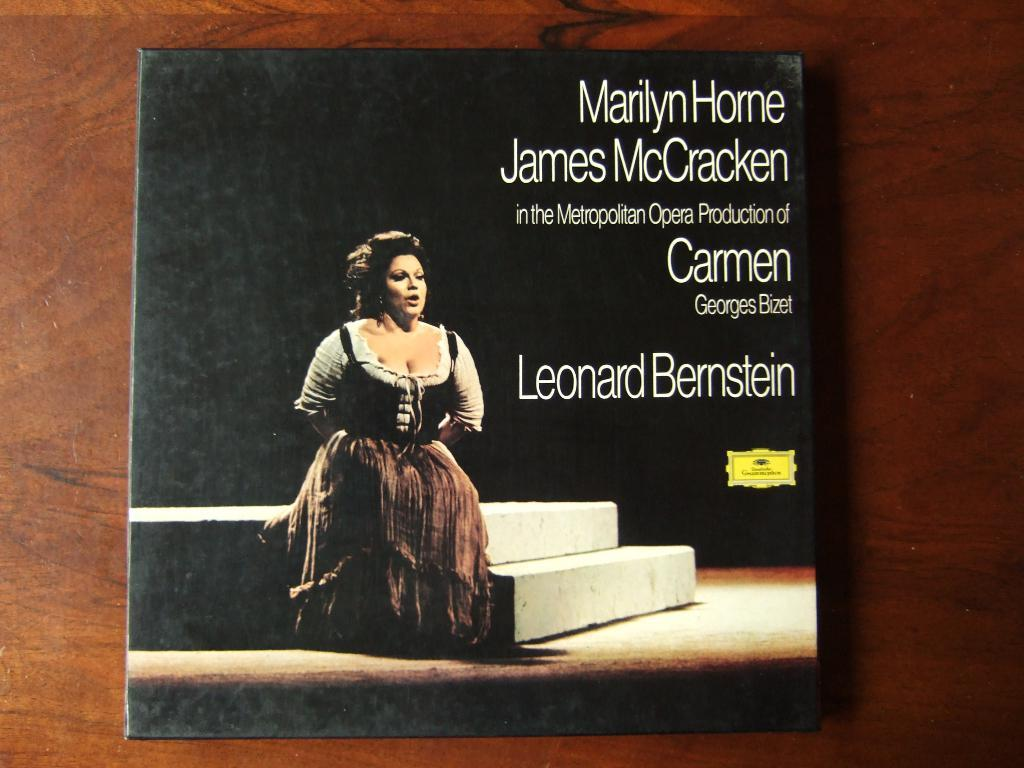<image>
Provide a brief description of the given image. the name Leonard is on the front of the book 